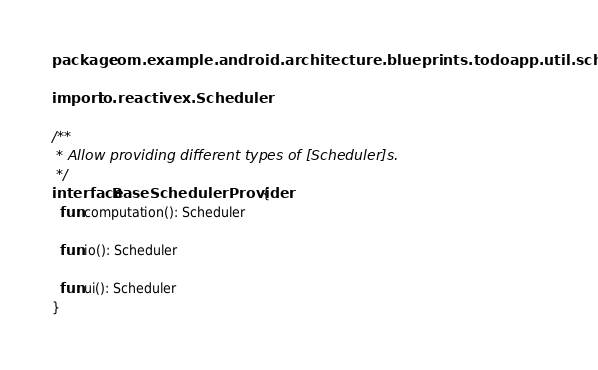Convert code to text. <code><loc_0><loc_0><loc_500><loc_500><_Kotlin_>package com.example.android.architecture.blueprints.todoapp.util.schedulers

import io.reactivex.Scheduler

/**
 * Allow providing different types of [Scheduler]s.
 */
interface BaseSchedulerProvider {
  fun computation(): Scheduler

  fun io(): Scheduler

  fun ui(): Scheduler
}
</code> 